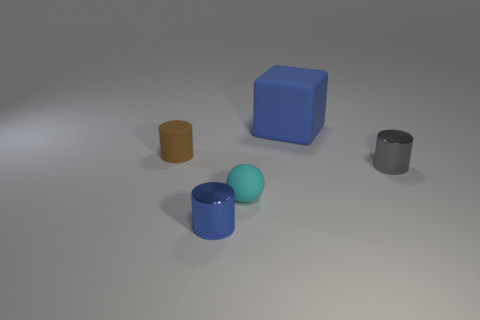Are there any tiny blue shiny cylinders in front of the metal cylinder that is to the left of the gray cylinder?
Provide a short and direct response. No. Are there any blue rubber things in front of the small gray object?
Offer a very short reply. No. Is the shape of the rubber object that is in front of the small gray shiny cylinder the same as  the small blue metallic object?
Offer a very short reply. No. What number of brown objects have the same shape as the tiny blue thing?
Provide a succinct answer. 1. Are there any tiny blue cylinders that have the same material as the ball?
Give a very brief answer. No. There is a small cyan sphere that is in front of the blue object behind the small brown rubber object; what is it made of?
Provide a succinct answer. Rubber. What size is the blue thing that is to the left of the rubber block?
Your answer should be compact. Small. Do the small rubber cylinder and the cylinder that is in front of the gray cylinder have the same color?
Provide a succinct answer. No. Are there any balls that have the same color as the block?
Offer a very short reply. No. Is the small brown cylinder made of the same material as the blue thing behind the tiny rubber cylinder?
Provide a succinct answer. Yes. 